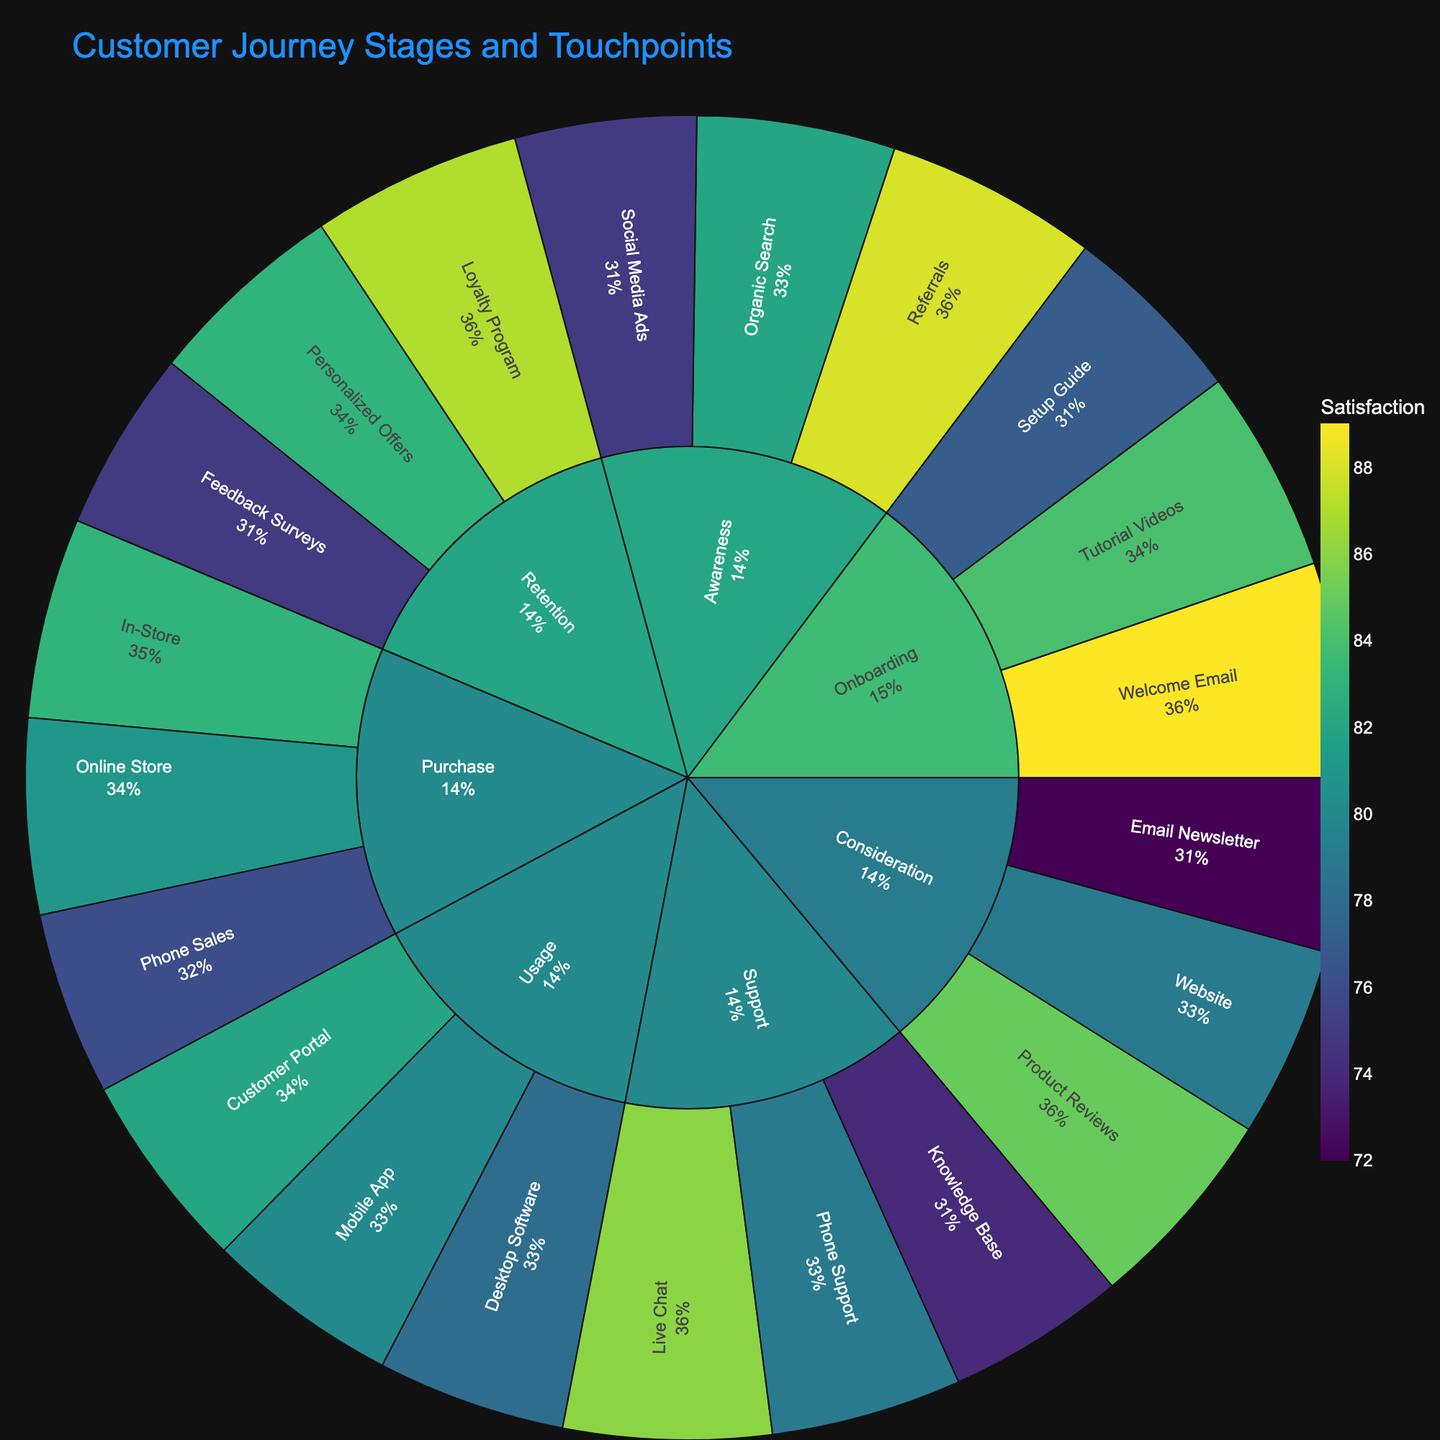What is the title of the Sunburst Plot? The title is located at the top of the plot, and it clearly indicates the focus of the visualization.
Answer: Customer Journey Stages and Touchpoints Which customer journey stage has the highest average satisfaction? Calculate the average satisfaction for each stage by summing the satisfaction scores of all touchpoints within the stage and dividing by the number of touchpoints. Compare the averages to find the highest.
Answer: Onboarding What is the satisfaction level of the "Organic Search" touchpoint? Locate the "Organic Search" touchpoint in the Awareness stage and find its associated satisfaction level.
Answer: 82 Compare the satisfaction levels of "Live Chat" and "Phone Support". Which one is higher? Locate both touchpoints in the Support stage and compare their satisfaction levels directly.
Answer: Live Chat (86 > 79 Phone Support) Which stage has the greatest number of touchpoints? Count the number of touchpoints under each stage in the Sunburst Plot and identify the stage with the highest count.
Answer: Support and Retention (each with 3 touchpoints) What is the average satisfaction for touchpoints in the "Purchase" stage? Sum the satisfaction scores of the touchpoints in the Purchase stage (Online Store, Phone Sales, In-Store) and divide by the number of touchpoints (3). Calculation: (81 + 76 + 83) / 3
Answer: 80 Which customer journey stage has the lowest satisfaction touchpoint? Identify the touchpoint with the lowest satisfaction score across all stages and determine its stage.
Answer: Support (Knowledge Base with 74) Compare the average satisfaction between the "Awareness" and "Support" stages. Which is higher? Calculate the average satisfaction for each stage by summing the scores of their touchpoints and dividing by the number of touchpoints. Compare the averages. Awareness: (75+82+88)/3, Support: (86+79+74)/3 → 81.67 vs 79.67
Answer: Awareness How does the satisfaction of "Customer Portal" in the Usage stage compare to the average for the Usage stage? Calculate the average satisfaction of Usage stage by summing the satisfaction of all touchpoints and dividing by the number of touchpoints, then compare "Customer Portal" satisfaction against this average. Average Usage: (80+78+82)/3 = 80, Customer Portal: 82
Answer: Customer Portal is higher What is the percentage contribution of the "Website" touchpoint to the total satisfaction of the "Consideration" stage? Sum satisfaction of all Consideration touchpoints, divide the satisfaction of the Website by this sum, and multiply by 100 for the percentage. Calculation: 79 / (79+85+72) * 100.
Answer: 30.9% 